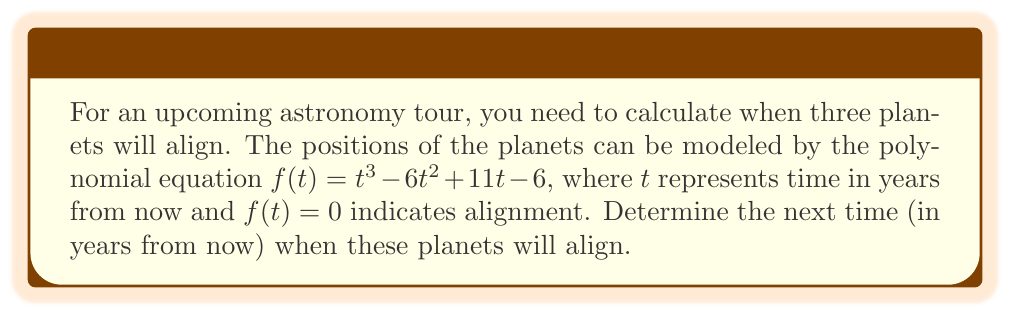Show me your answer to this math problem. To find when the planets align, we need to solve the equation $f(t) = 0$:

$$t^3 - 6t^2 + 11t - 6 = 0$$

This is a cubic equation. We can solve it using the following steps:

1) First, let's check if there's a rational root using the rational root theorem. Possible rational roots are factors of the constant term: $\pm 1, \pm 2, \pm 3, \pm 6$

2) Testing these values, we find that $t = 1$ is a root:
   $f(1) = 1^3 - 6(1)^2 + 11(1) - 6 = 1 - 6 + 11 - 6 = 0$

3) Now we can factor out $(t-1)$:
   $t^3 - 6t^2 + 11t - 6 = (t-1)(t^2 - 5t + 6)$

4) The quadratic factor can be solved using the quadratic formula:
   $t = \frac{-b \pm \sqrt{b^2 - 4ac}}{2a}$

   Where $a=1$, $b=-5$, and $c=6$

5) Plugging in these values:
   $t = \frac{5 \pm \sqrt{25 - 24}}{2} = \frac{5 \pm 1}{2}$

6) This gives us two more roots:
   $t = 3$ and $t = 2$

Therefore, the three roots are 1, 2, and 3 years from now. The question asks for the next time, which is the smallest positive root.
Answer: 1 year 